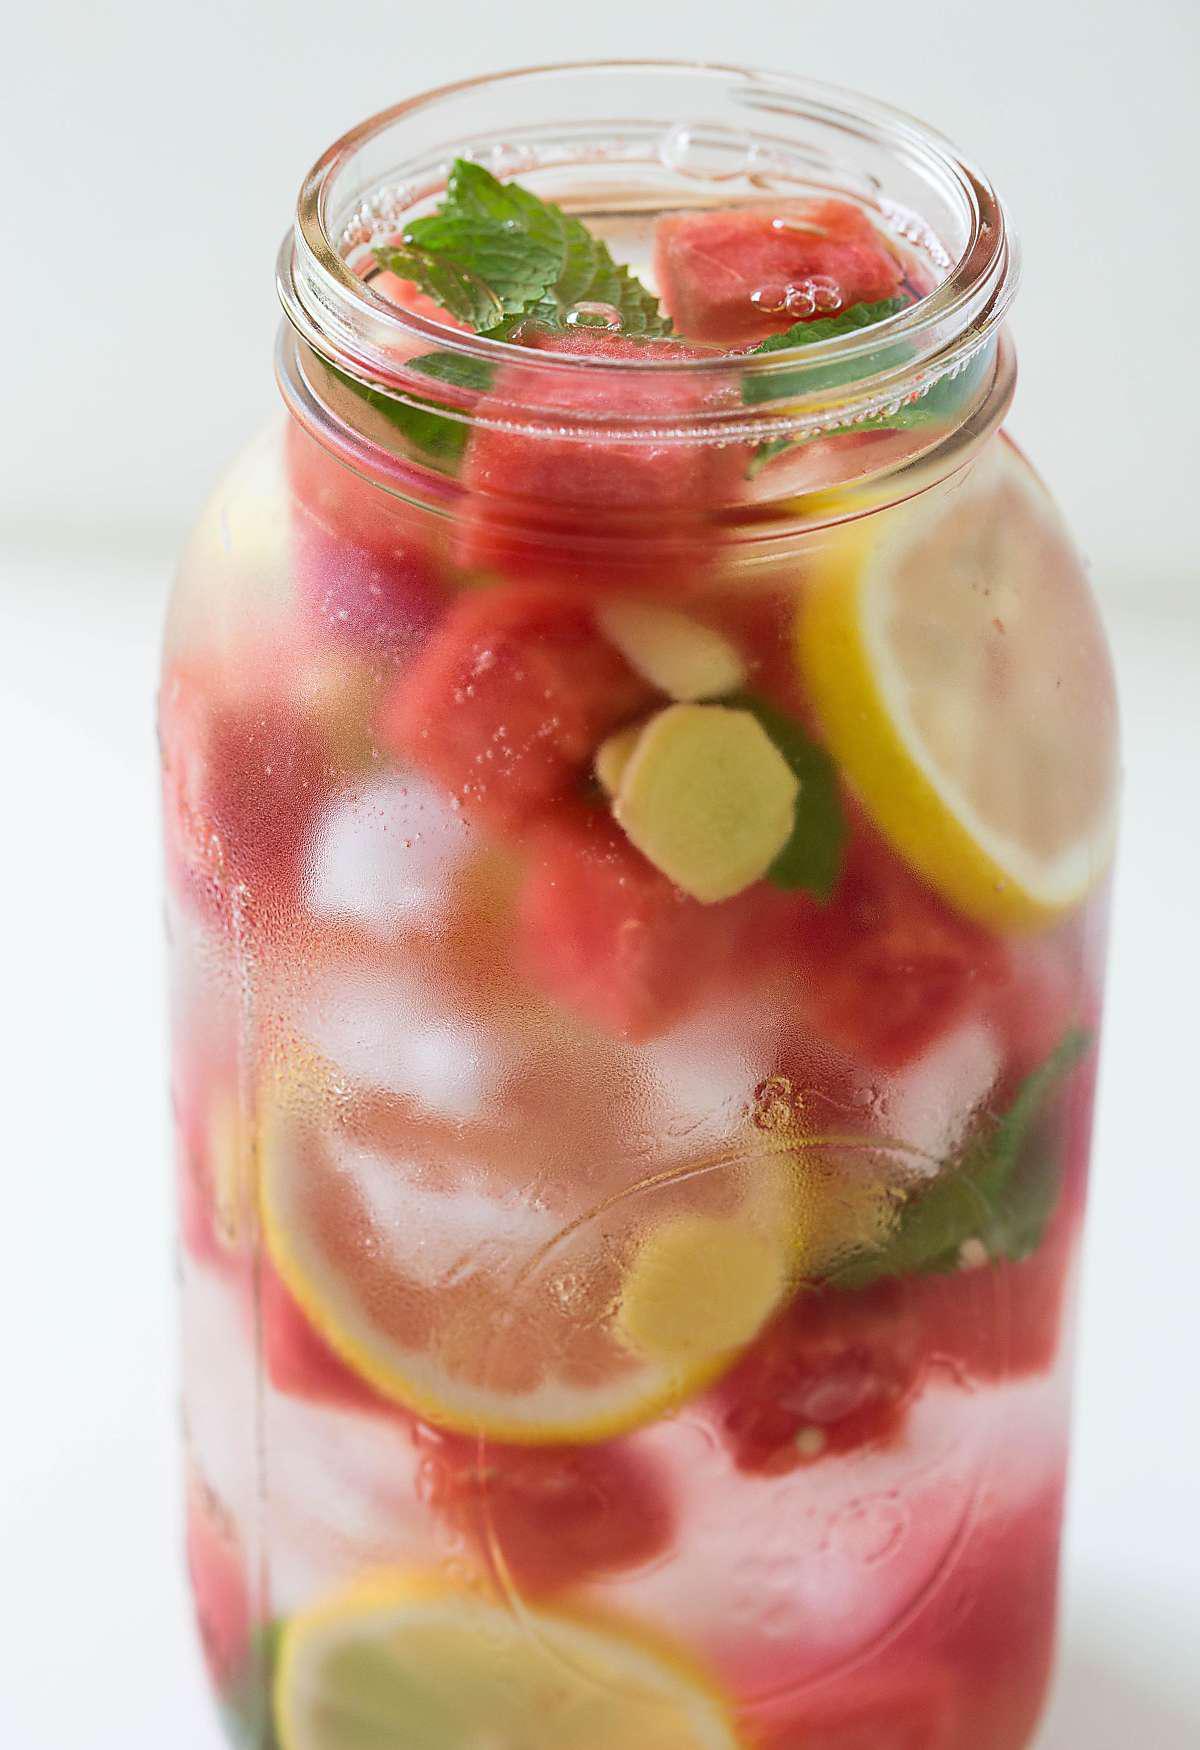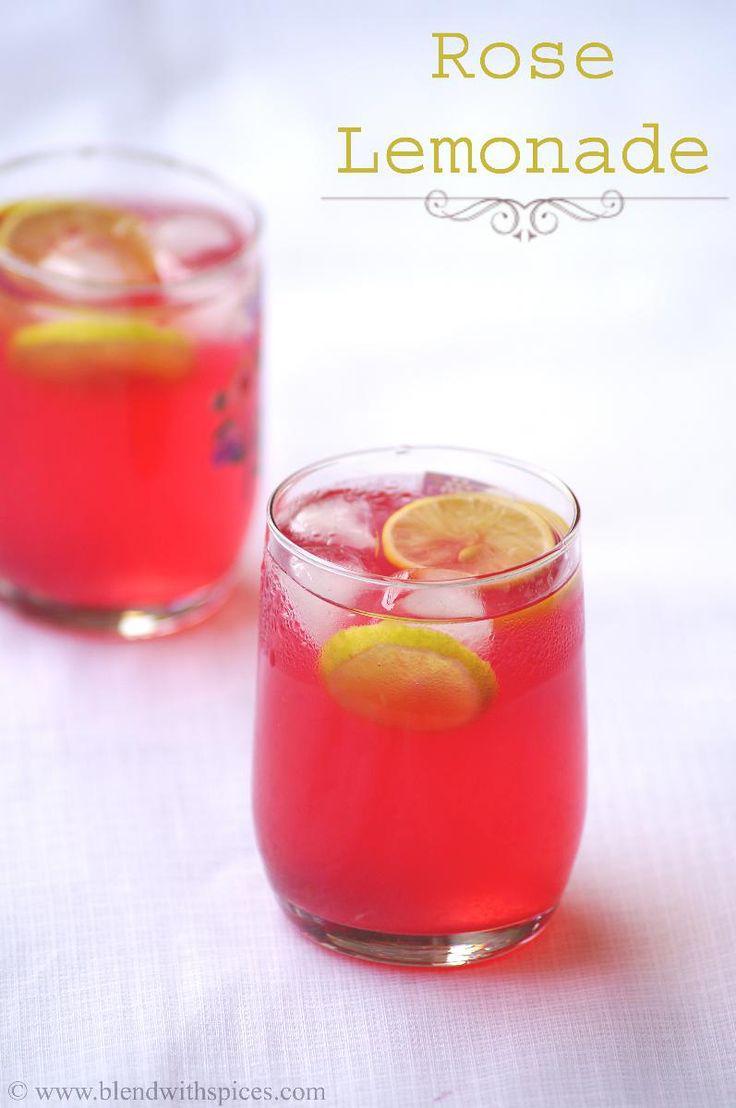The first image is the image on the left, the second image is the image on the right. For the images displayed, is the sentence "At least some of the beverages are served in jars and have straws inserted." factually correct? Answer yes or no. No. The first image is the image on the left, the second image is the image on the right. Considering the images on both sides, is "Both images show a red drink in a clear glass with a lemon slice on the edge of the glass" valid? Answer yes or no. No. 